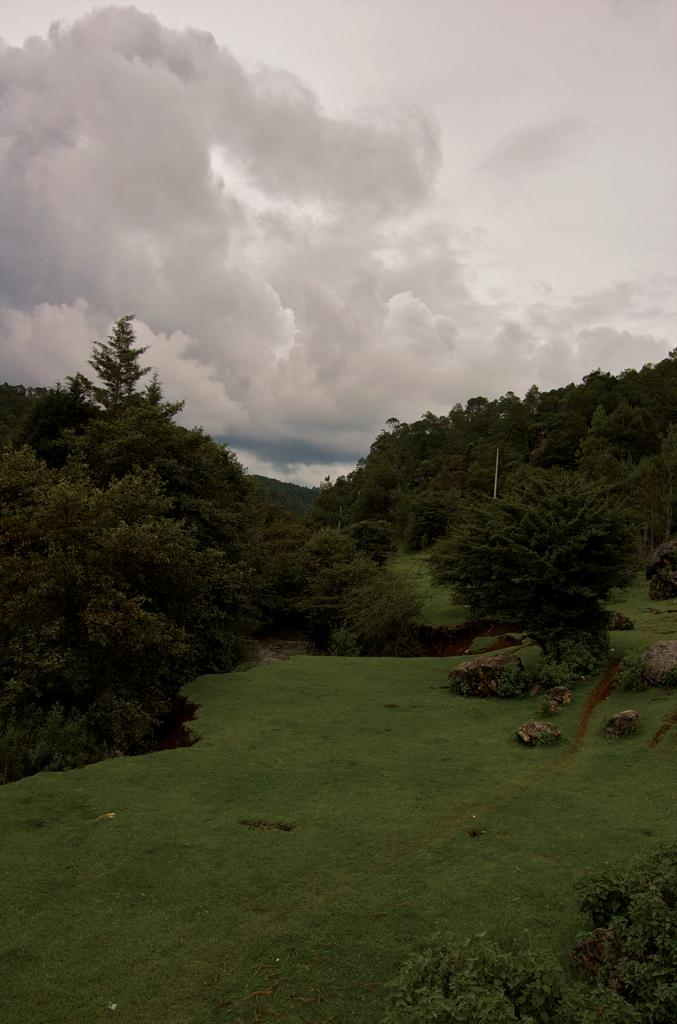What type of natural formation can be seen in the image? There are mountains in the image. What vegetation is present on the mountains? Trees are present on the mountains, and grass is visible on the mountains. What is visible at the top of the image? The sky is visible at the top of the image. Can you see any screws holding the mountains together in the image? There are no screws present in the image; the mountains are a natural formation. 